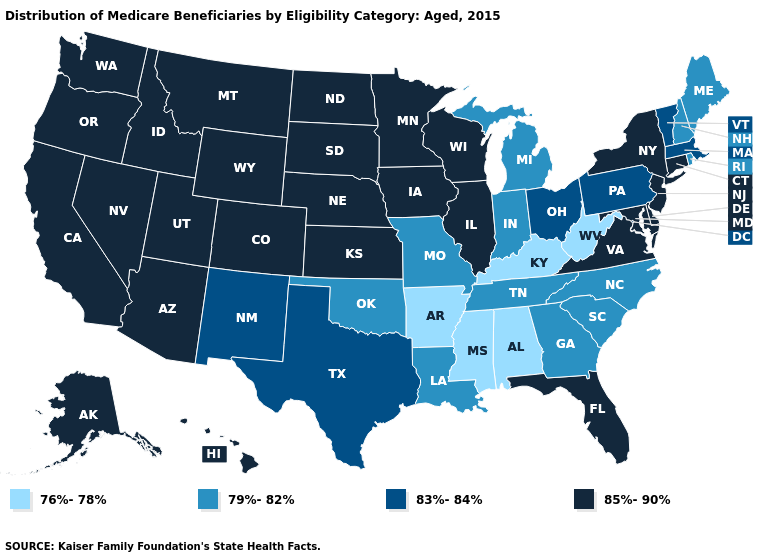What is the value of Oregon?
Give a very brief answer. 85%-90%. Is the legend a continuous bar?
Short answer required. No. What is the highest value in states that border Arizona?
Answer briefly. 85%-90%. Does Vermont have a higher value than Minnesota?
Short answer required. No. Name the states that have a value in the range 83%-84%?
Give a very brief answer. Massachusetts, New Mexico, Ohio, Pennsylvania, Texas, Vermont. Name the states that have a value in the range 83%-84%?
Quick response, please. Massachusetts, New Mexico, Ohio, Pennsylvania, Texas, Vermont. What is the value of Georgia?
Be succinct. 79%-82%. Among the states that border Montana , which have the lowest value?
Write a very short answer. Idaho, North Dakota, South Dakota, Wyoming. Among the states that border Florida , which have the highest value?
Concise answer only. Georgia. Name the states that have a value in the range 76%-78%?
Concise answer only. Alabama, Arkansas, Kentucky, Mississippi, West Virginia. What is the lowest value in the Northeast?
Keep it brief. 79%-82%. Which states hav the highest value in the South?
Write a very short answer. Delaware, Florida, Maryland, Virginia. What is the value of Connecticut?
Be succinct. 85%-90%. Does Arkansas have the lowest value in the USA?
Concise answer only. Yes. 